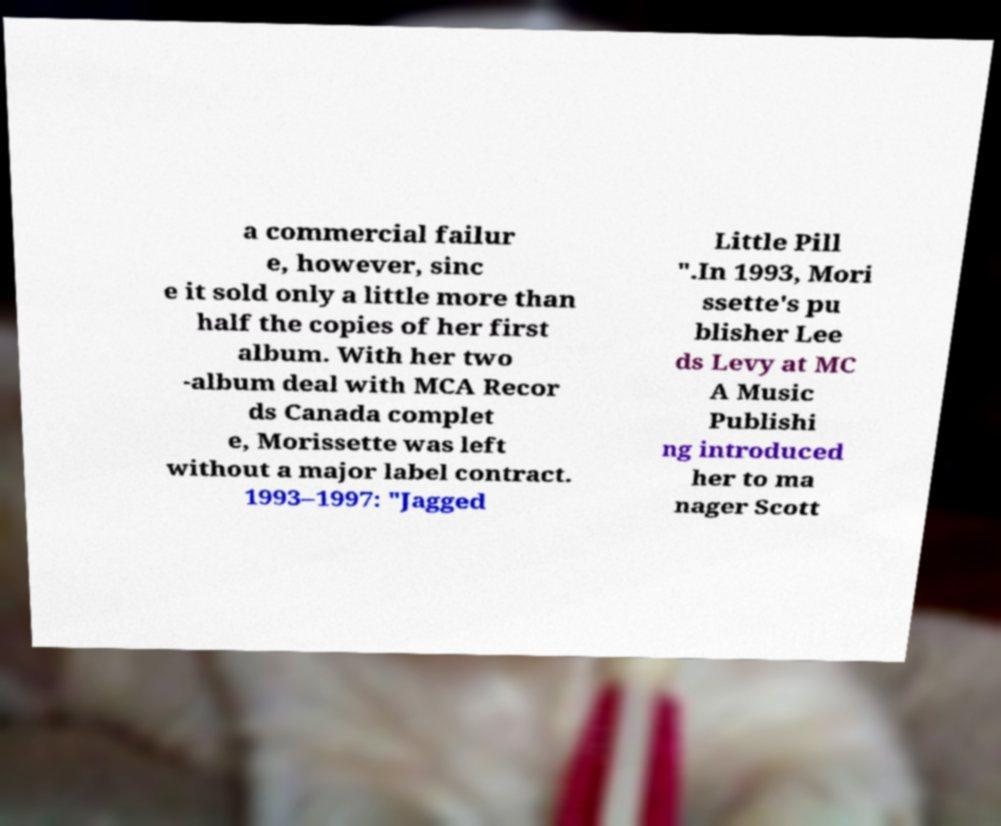There's text embedded in this image that I need extracted. Can you transcribe it verbatim? a commercial failur e, however, sinc e it sold only a little more than half the copies of her first album. With her two -album deal with MCA Recor ds Canada complet e, Morissette was left without a major label contract. 1993–1997: "Jagged Little Pill ".In 1993, Mori ssette's pu blisher Lee ds Levy at MC A Music Publishi ng introduced her to ma nager Scott 